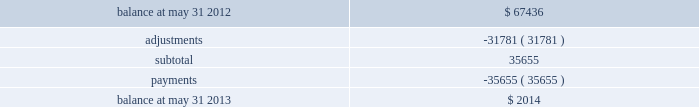Our initial estimate of fraud losses , fines and other charges on our understanding of the rules and operating regulations published by the networks and preliminary communications with the networks .
We have now reached resolution with and made payments to the networks , resulting in charges that were less than our initial estimates .
The primary difference between our initial estimates and the final charges relates to lower fraud related costs attributed to this event than previously expected .
The table reflects the activity in our accrual for fraud losses , fines and other charges for the twelve months ended may 31 , 2013 ( in thousands ) : .
We were insured under policies that provided coverage of certain costs associated with this event .
The policies provided a total of $ 30.0 million in policy limits and contained various sub-limits of liability and other terms , conditions and limitations , including a $ 1.0 million deductible per claim .
As of fiscal year 2013 , we received assessments from certain networks and submitted additional claims to the insurers and recorded $ 20.0 million in additional insurance recoveries based on our negotiations with our insurers .
We will record receivables for any additional recoveries in the periods in which we determine such recovery is probable and the amount can be reasonably estimated .
A class action arising out of the processing system intrusion was filed against us on april 4 , 2012 by natalie willingham ( individually and on behalf of a putative nationwide class ) ( the 201cplaintiff 201d ) .
Specifically , ms .
Willingham alleged that we failed to maintain reasonable and adequate procedures to protect her personally identifiable information ( 201cpii 201d ) which she claims resulted in two fraudulent charges on her credit card in march 2012 .
Further , ms .
Willingham asserted that we failed to timely notify the public of the data breach .
Based on these allegations , ms .
Willingham asserted claims for negligence , violation of the federal stored communications act , willful violation of the fair credit reporting act , negligent violation of the fair credit reporting act , violation of georgia 2019s unfair and deceptive trade practices act , negligence per se , breach of third-party beneficiary contract , and breach of implied contract .
Ms .
Willingham sought an unspecified amount of damages and injunctive relief .
The lawsuit was filed in the united states district court for the northern district of georgia .
On may 14 , 2012 , we filed a motion to dismiss .
On july 11 , 2012 , plaintiff filed a motion for leave to amend her complaint , and on july 16 , 2012 , the court granted that motion .
She then filed an amended complaint on july 16 , 2012 .
The amended complaint did not add any new causes of action .
Instead , it added two new named plaintiffs ( nadine and robert hielscher ) ( together with plaintiff , the 201cplaintiffs 201d ) and dropped plaintiff 2019s claim for negligence per se .
On august 16 , 2012 , we filed a motion to dismiss the plaintiffs 2019 amended complaint .
The plaintiffs filed their response in opposition to our motion to dismiss on october 5 , 2012 , and we subsequently filed our reply brief on october 22 , 2012 .
The magistrate judge issued a report and recommendation recommending dismissal of all of plaintiffs 2019 claims with prejudice .
The plaintiffs subsequently agreed to voluntarily dismiss the lawsuit with prejudice , with each party bearing its own fees and costs .
This was the only consideration exchanged by the parties in connection with plaintiffs 2019 voluntary dismissal with prejudice of the lawsuit .
The lawsuit was dismissed with prejudice on march 6 , 2013 .
Note 3 2014settlement processing assets and obligations we are designated as a merchant service provider by mastercard and an independent sales organization by visa .
These designations are dependent upon member clearing banks ( 201cmember 201d ) sponsoring us and our adherence to the standards of the networks .
We have primary financial institution sponsors in the various markets where we facilitate payment transactions with whom we have sponsorship or depository and clearing agreements .
These agreements allow us to route transactions under the member banks 2019 control and identification numbers to clear credit card transactions through mastercard and visa .
In certain markets , we are members in various payment networks , allowing us to process and fund transactions without third-party sponsorship. .
What portion of the beginning balance of accrual for fraud losses is regulated through adjustments? 
Computations: (31781 / 67436)
Answer: 0.47128. 